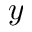<formula> <loc_0><loc_0><loc_500><loc_500>y</formula> 